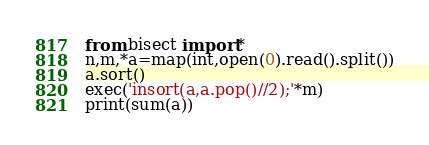Convert code to text. <code><loc_0><loc_0><loc_500><loc_500><_Python_>from bisect import*
n,m,*a=map(int,open(0).read().split())
a.sort()
exec('insort(a,a.pop()//2);'*m)
print(sum(a))</code> 